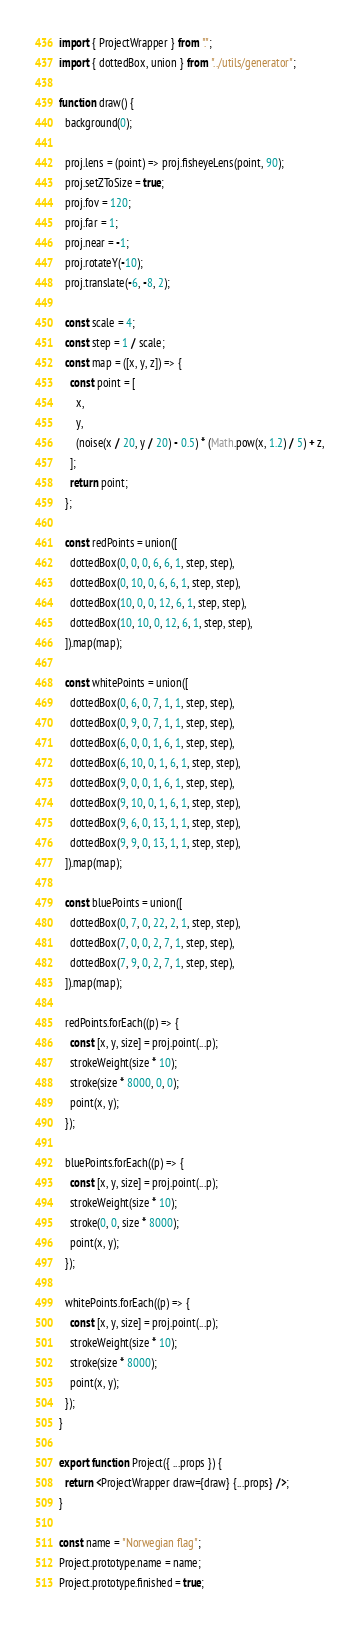Convert code to text. <code><loc_0><loc_0><loc_500><loc_500><_JavaScript_>import { ProjectWrapper } from ".";
import { dottedBox, union } from "../utils/generator";

function draw() {
  background(0);

  proj.lens = (point) => proj.fisheyeLens(point, 90);
  proj.setZToSize = true;
  proj.fov = 120;
  proj.far = 1;
  proj.near = -1;
  proj.rotateY(-10);
  proj.translate(-6, -8, 2);

  const scale = 4;
  const step = 1 / scale;
  const map = ([x, y, z]) => {
    const point = [
      x,
      y,
      (noise(x / 20, y / 20) - 0.5) * (Math.pow(x, 1.2) / 5) + z,
    ];
    return point;
  };

  const redPoints = union([
    dottedBox(0, 0, 0, 6, 6, 1, step, step),
    dottedBox(0, 10, 0, 6, 6, 1, step, step),
    dottedBox(10, 0, 0, 12, 6, 1, step, step),
    dottedBox(10, 10, 0, 12, 6, 1, step, step),
  ]).map(map);

  const whitePoints = union([
    dottedBox(0, 6, 0, 7, 1, 1, step, step),
    dottedBox(0, 9, 0, 7, 1, 1, step, step),
    dottedBox(6, 0, 0, 1, 6, 1, step, step),
    dottedBox(6, 10, 0, 1, 6, 1, step, step),
    dottedBox(9, 0, 0, 1, 6, 1, step, step),
    dottedBox(9, 10, 0, 1, 6, 1, step, step),
    dottedBox(9, 6, 0, 13, 1, 1, step, step),
    dottedBox(9, 9, 0, 13, 1, 1, step, step),
  ]).map(map);

  const bluePoints = union([
    dottedBox(0, 7, 0, 22, 2, 1, step, step),
    dottedBox(7, 0, 0, 2, 7, 1, step, step),
    dottedBox(7, 9, 0, 2, 7, 1, step, step),
  ]).map(map);

  redPoints.forEach((p) => {
    const [x, y, size] = proj.point(...p);
    strokeWeight(size * 10);
    stroke(size * 8000, 0, 0);
    point(x, y);
  });

  bluePoints.forEach((p) => {
    const [x, y, size] = proj.point(...p);
    strokeWeight(size * 10);
    stroke(0, 0, size * 8000);
    point(x, y);
  });

  whitePoints.forEach((p) => {
    const [x, y, size] = proj.point(...p);
    strokeWeight(size * 10);
    stroke(size * 8000);
    point(x, y);
  });
}

export function Project({ ...props }) {
  return <ProjectWrapper draw={draw} {...props} />;
}

const name = "Norwegian flag";
Project.prototype.name = name;
Project.prototype.finished = true;
</code> 